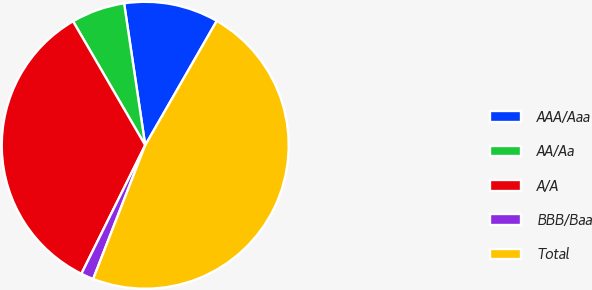Convert chart to OTSL. <chart><loc_0><loc_0><loc_500><loc_500><pie_chart><fcel>AAA/Aaa<fcel>AA/Aa<fcel>A/A<fcel>BBB/Baa<fcel>Total<nl><fcel>10.66%<fcel>6.04%<fcel>34.27%<fcel>1.43%<fcel>47.6%<nl></chart> 